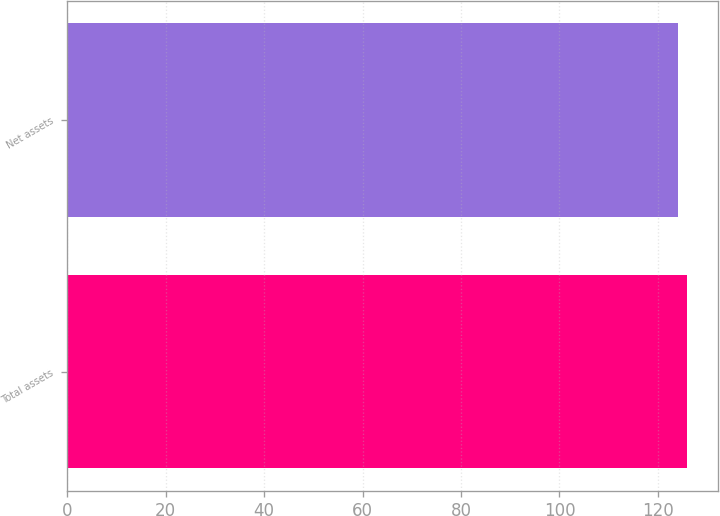Convert chart to OTSL. <chart><loc_0><loc_0><loc_500><loc_500><bar_chart><fcel>Total assets<fcel>Net assets<nl><fcel>126<fcel>124<nl></chart> 